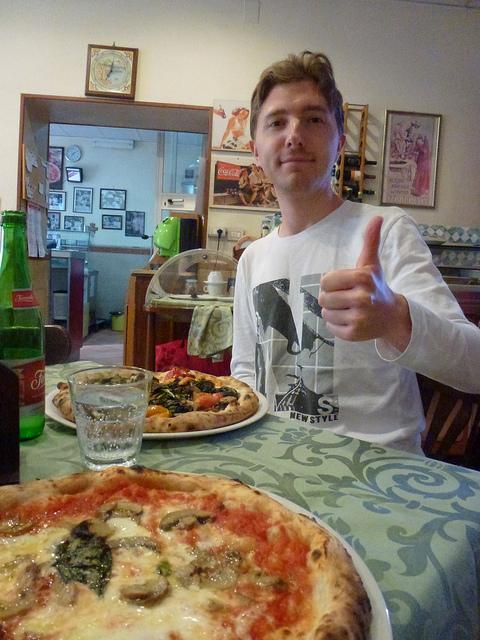Is the glass full?
Give a very brief answer. Yes. What is the man doing with his left hand?
Concise answer only. Thumbs up. How many pizzas are on the table?
Give a very brief answer. 2. Why are there several plates of pizza?
Keep it brief. Several people eating. Does the man have a vision problem?
Keep it brief. No. Is the photographer dining alone?
Concise answer only. No. How many people are dining?
Quick response, please. 1. Are these both vegetarian pizzas?
Give a very brief answer. Yes. What is in green bottle?
Concise answer only. Soda. How many hands are in the image?
Concise answer only. 1. Are these pepperoni pizzas?
Concise answer only. No. Does the table have a tablecloth on it?
Write a very short answer. Yes. 